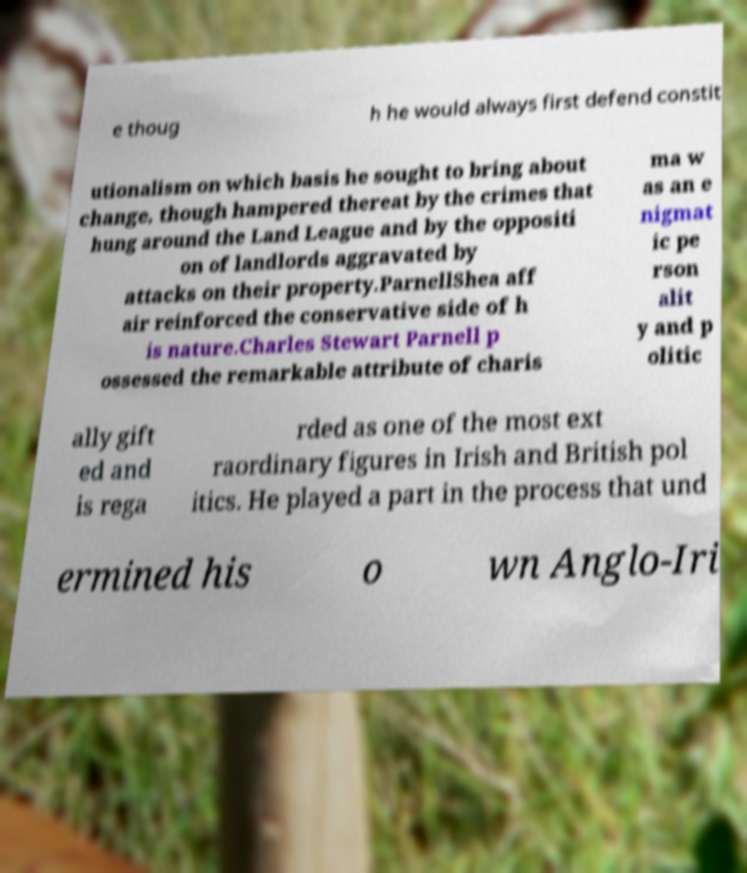Can you accurately transcribe the text from the provided image for me? e thoug h he would always first defend constit utionalism on which basis he sought to bring about change, though hampered thereat by the crimes that hung around the Land League and by the oppositi on of landlords aggravated by attacks on their property.ParnellShea aff air reinforced the conservative side of h is nature.Charles Stewart Parnell p ossessed the remarkable attribute of charis ma w as an e nigmat ic pe rson alit y and p olitic ally gift ed and is rega rded as one of the most ext raordinary figures in Irish and British pol itics. He played a part in the process that und ermined his o wn Anglo-Iri 